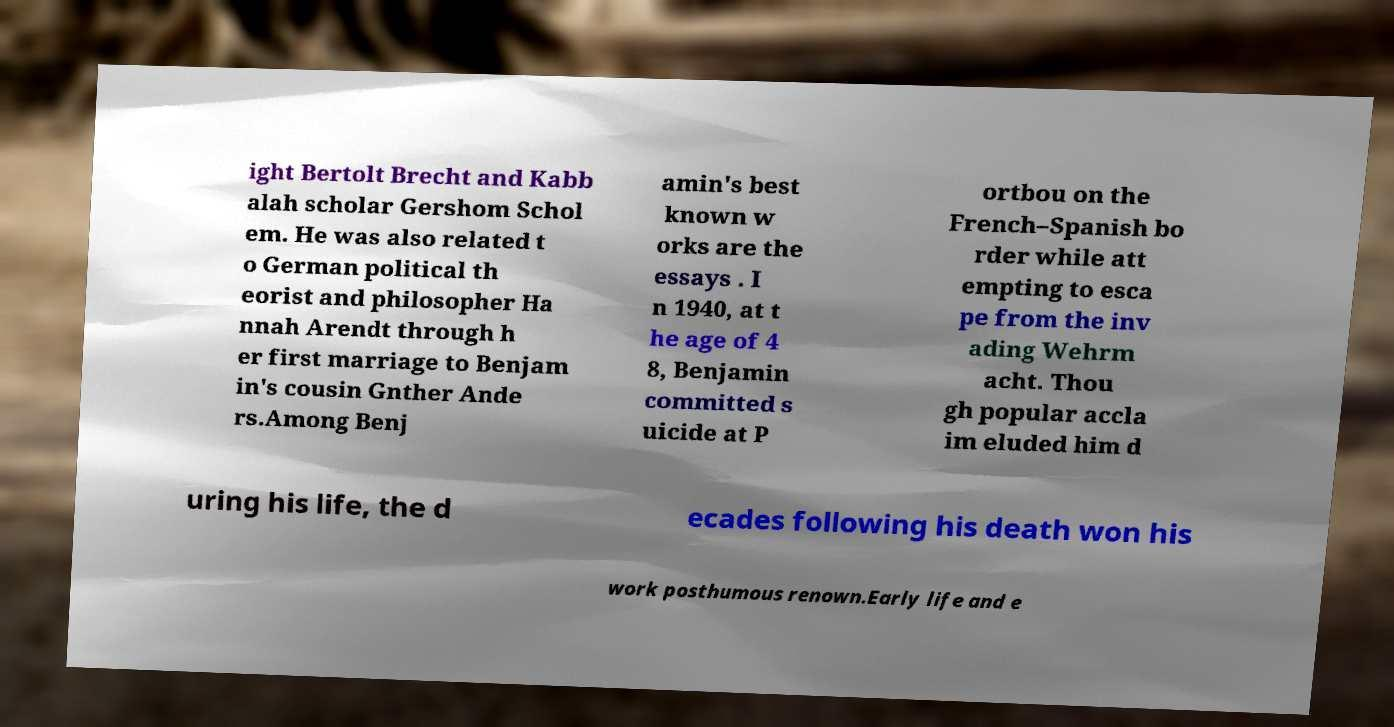Please identify and transcribe the text found in this image. ight Bertolt Brecht and Kabb alah scholar Gershom Schol em. He was also related t o German political th eorist and philosopher Ha nnah Arendt through h er first marriage to Benjam in's cousin Gnther Ande rs.Among Benj amin's best known w orks are the essays . I n 1940, at t he age of 4 8, Benjamin committed s uicide at P ortbou on the French–Spanish bo rder while att empting to esca pe from the inv ading Wehrm acht. Thou gh popular accla im eluded him d uring his life, the d ecades following his death won his work posthumous renown.Early life and e 